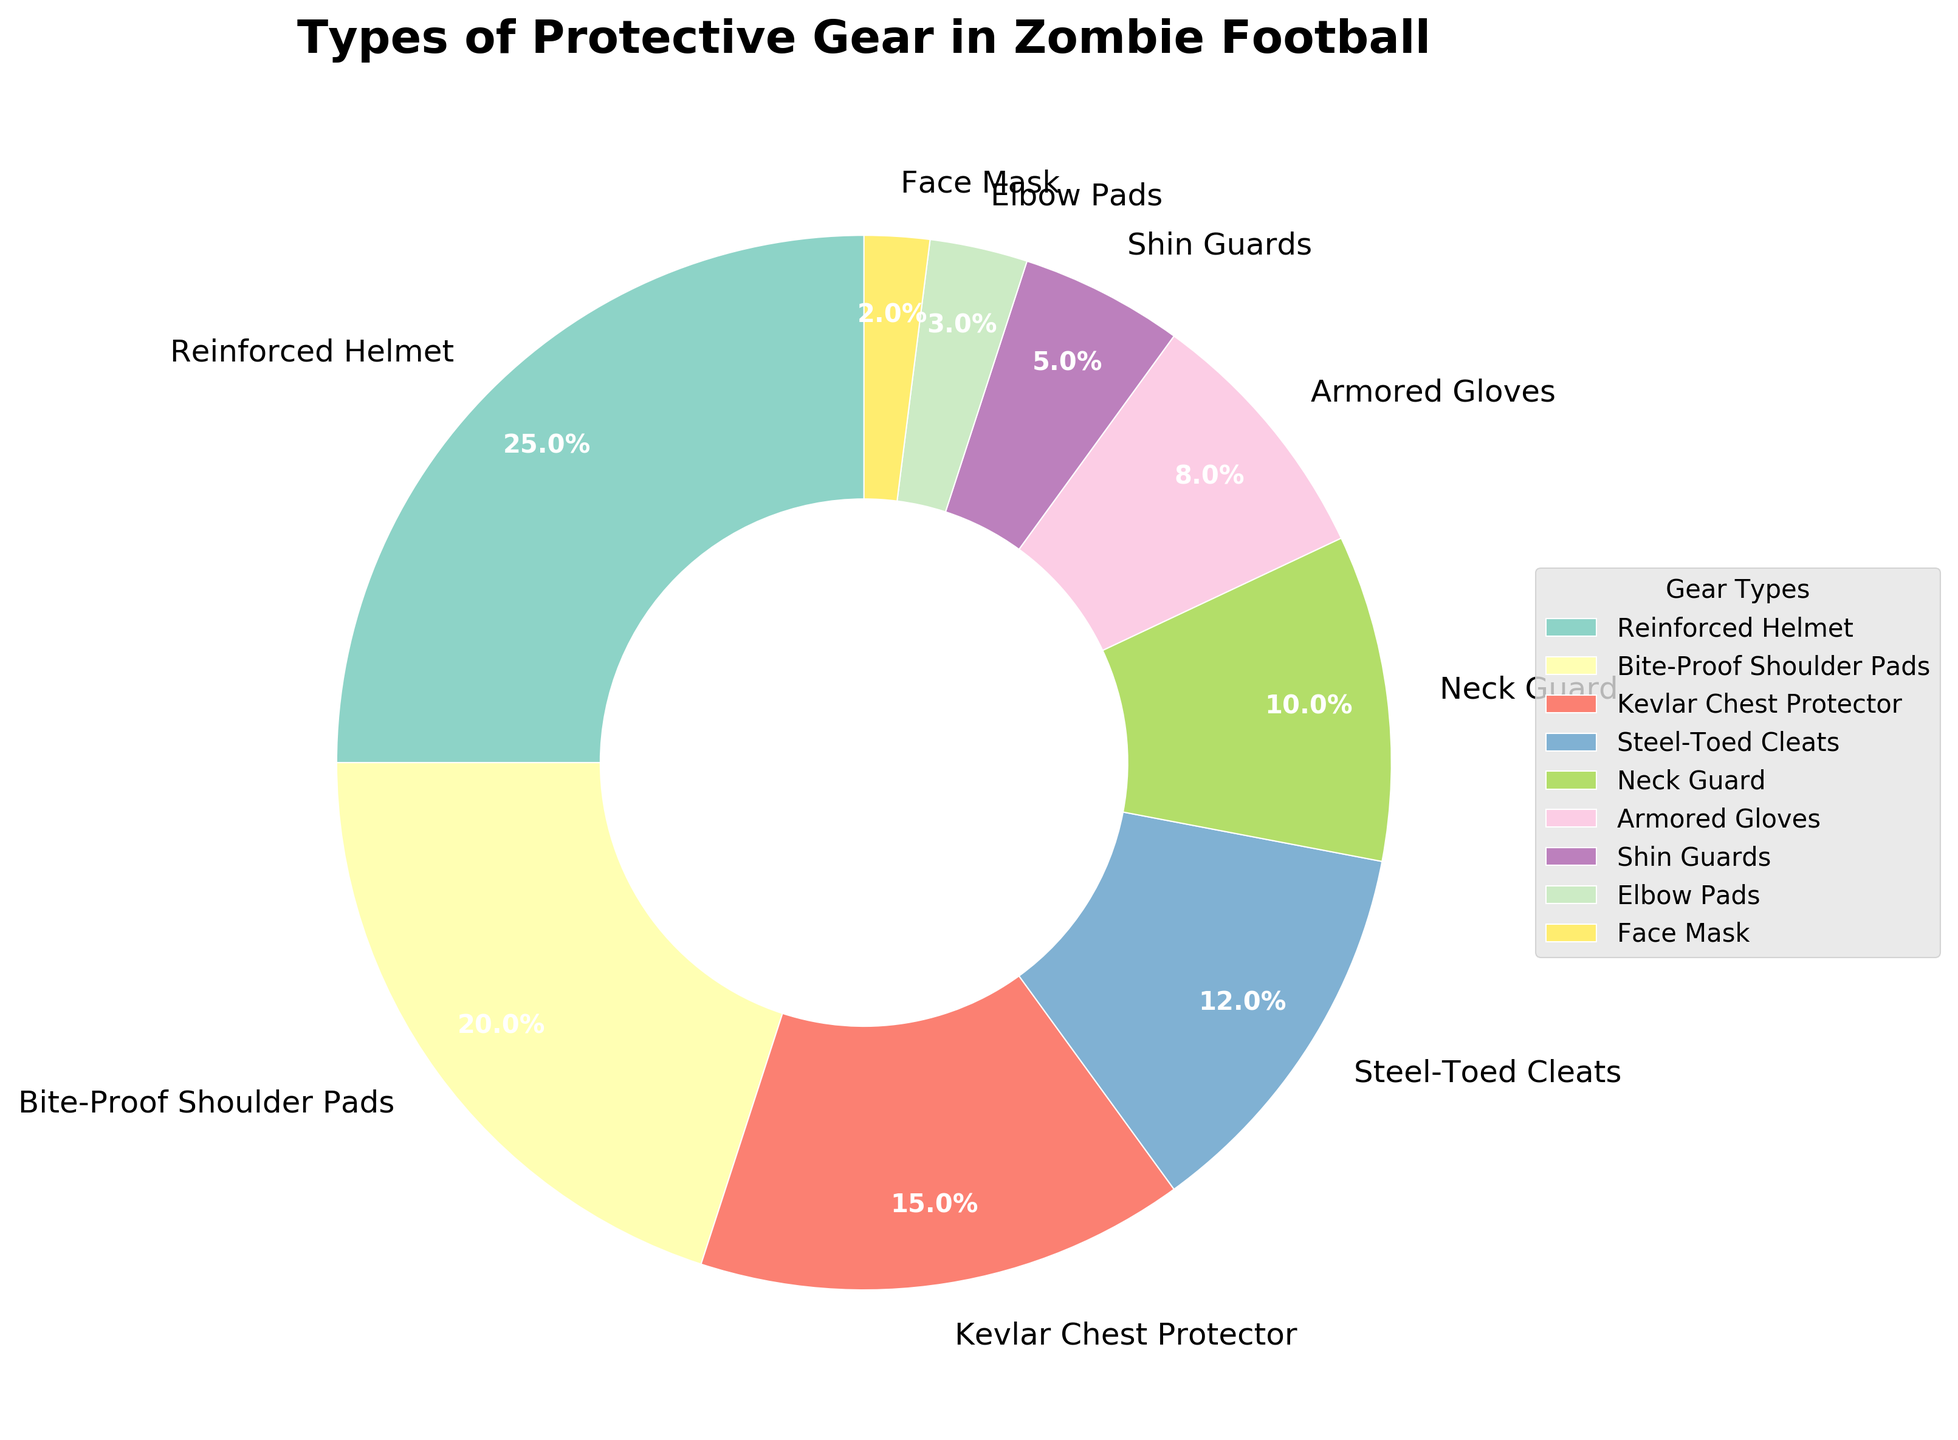Which type of protective gear is used the most in zombie football? According to the pie chart, the "Reinforced Helmet" has the highest percentage, indicating it is the most used type of protective gear in zombie football.
Answer: Reinforced Helmet How much more frequently are Armored Gloves used compared to Elbow Pads? The percentage for Armored Gloves is 8%, and for Elbow Pads, it is 3%. The difference is calculated as 8% - 3% = 5%.
Answer: 5% What is the total percentage of Steel-Toed Cleats and Neck Guard combined? The percentage for Steel-Toed Cleats is 12%, and for Neck Guard, it is 10%. The combined percentage is 12% + 10% = 22%.
Answer: 22% Which protective gear has a smaller percentage: Shin Guards or Face Mask? The pie chart shows that the Shin Guards have a percentage of 5%, while the Face Mask has a smaller percentage of 2%.
Answer: Face Mask Identify two types of protective gear that together make up for half of the total usage. The Reinforced Helmet (25%) and Bite-Proof Shoulder Pads (20%) together contribute 25% + 20% = 45% of the total, which is close to half.
Answer: Reinforced Helmet and Bite-Proof Shoulder Pads What percentage of protective gear usage is represented by Kevlar Chest Protector, Steel-Toed Cleats, and Armored Gloves combined? The percentages for Kevlar Chest Protector, Steel-Toed Cleats, and Armored Gloves are 15%, 12%, and 8% respectively. The total is 15% + 12% + 8% = 35%.
Answer: 35% Which category has a larger percentage: Kevlar Chest Protector or Bite-Proof Shoulder Pads? The pie chart shows that Bite-Proof Shoulder Pads have a larger percentage (20%) compared to Kevlar Chest Protector (15%).
Answer: Bite-Proof Shoulder Pads What is the cumulative percentage of the three least used types of protective gear? The three least used types of protective gear, according to the chart, are Elbow Pads (3%), Face Mask (2%), and Shin Guards (5%). Their cumulative percentage is 3% + 2% + 5% = 10%.
Answer: 10% How does the percentage of usage for Neck Guard compare to that of the Armored Gloves? The Neck Guard has a percentage of 10%, while Armored Gloves have a smaller percentage of 8%. Therefore, Neck Guard usage is higher.
Answer: Neck Guard 